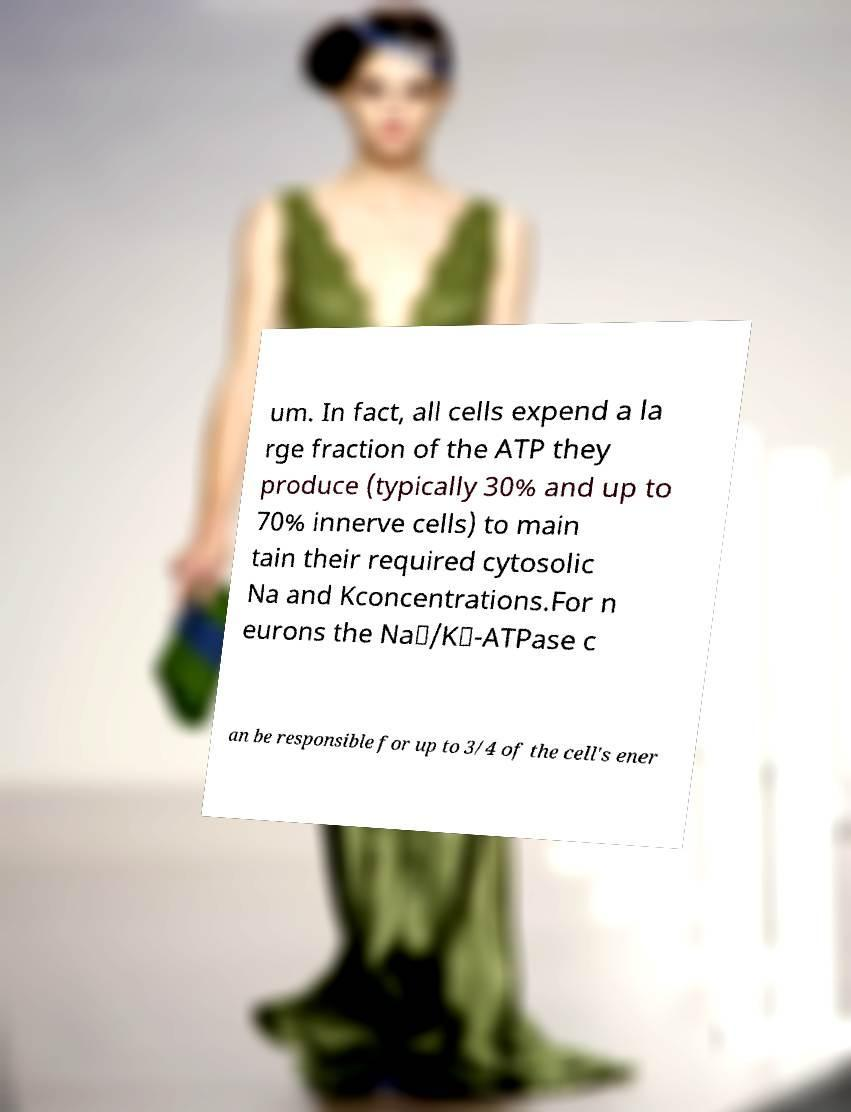Please identify and transcribe the text found in this image. um. In fact, all cells expend a la rge fraction of the ATP they produce (typically 30% and up to 70% innerve cells) to main tain their required cytosolic Na and Kconcentrations.For n eurons the Na⁺/K⁺-ATPase c an be responsible for up to 3/4 of the cell's ener 